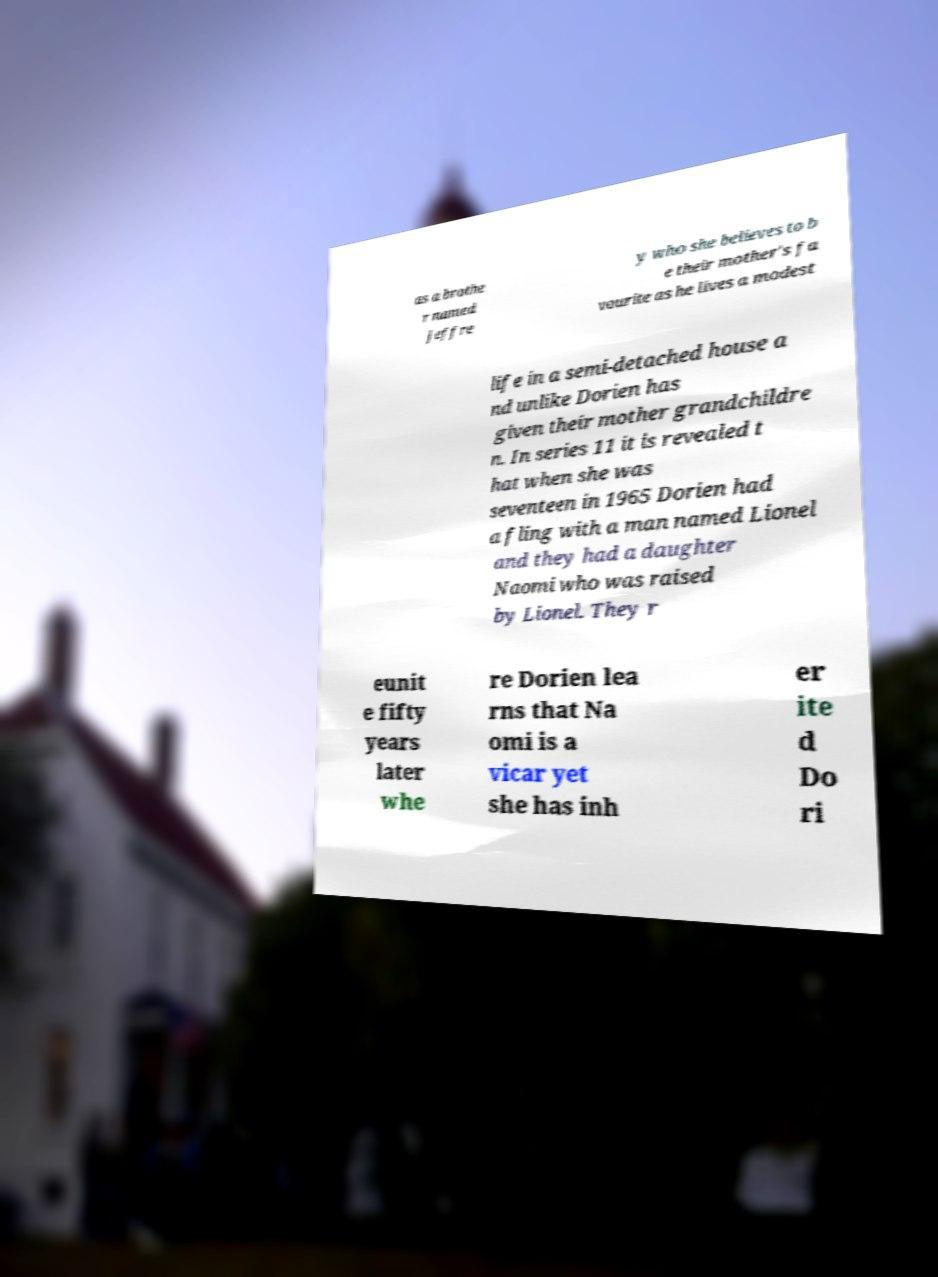Could you assist in decoding the text presented in this image and type it out clearly? as a brothe r named Jeffre y who she believes to b e their mother's fa vourite as he lives a modest life in a semi-detached house a nd unlike Dorien has given their mother grandchildre n. In series 11 it is revealed t hat when she was seventeen in 1965 Dorien had a fling with a man named Lionel and they had a daughter Naomi who was raised by Lionel. They r eunit e fifty years later whe re Dorien lea rns that Na omi is a vicar yet she has inh er ite d Do ri 